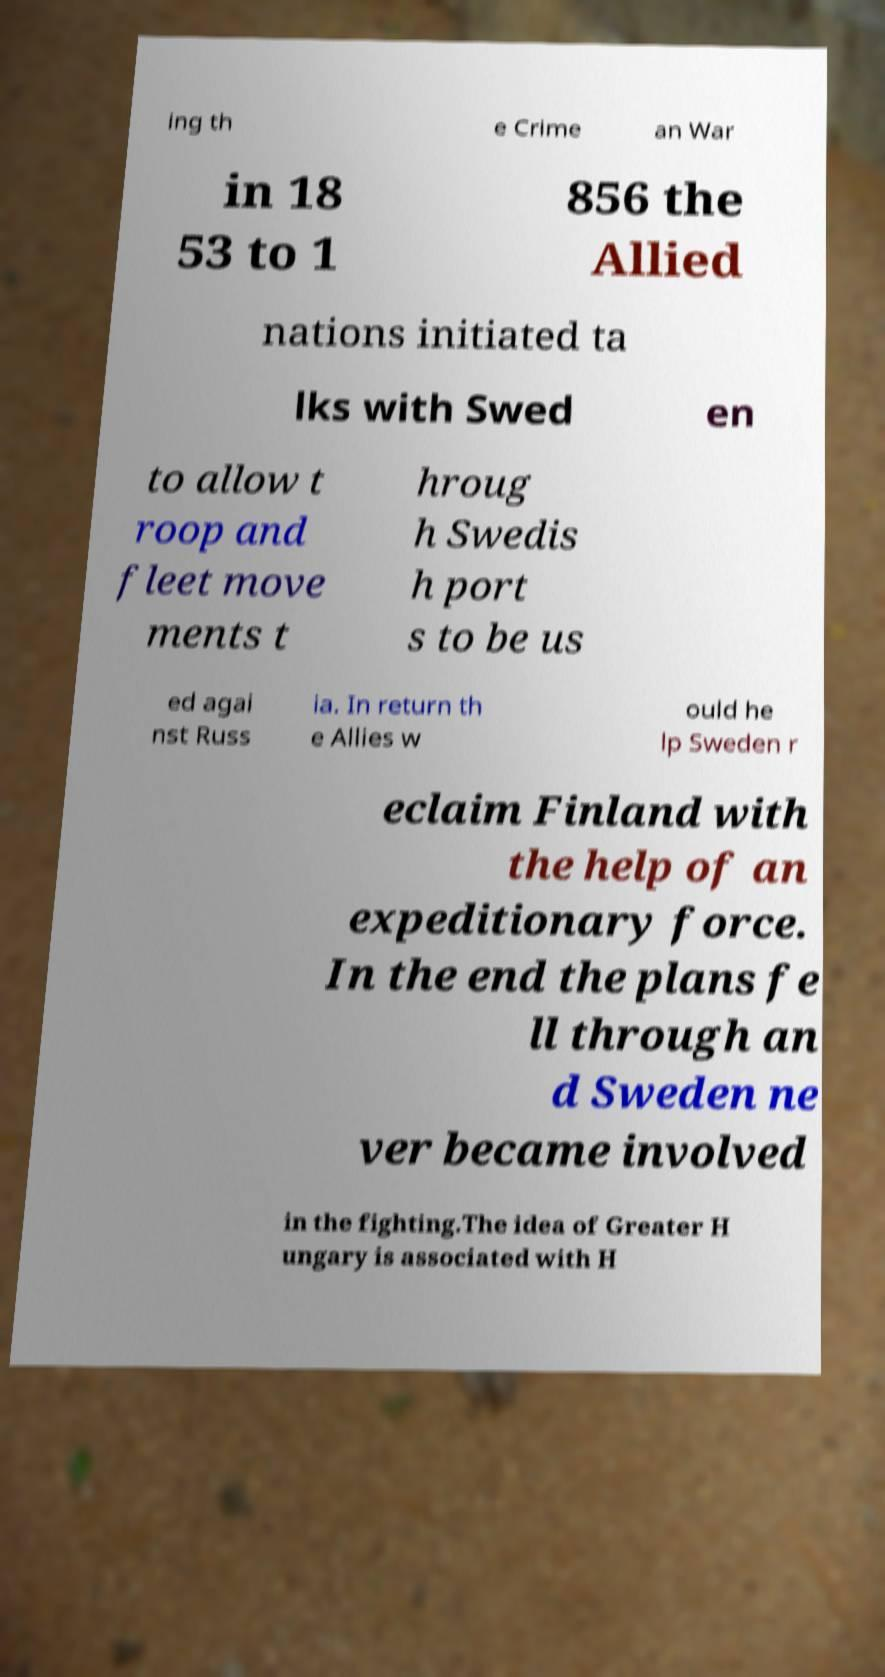Can you read and provide the text displayed in the image?This photo seems to have some interesting text. Can you extract and type it out for me? ing th e Crime an War in 18 53 to 1 856 the Allied nations initiated ta lks with Swed en to allow t roop and fleet move ments t hroug h Swedis h port s to be us ed agai nst Russ ia. In return th e Allies w ould he lp Sweden r eclaim Finland with the help of an expeditionary force. In the end the plans fe ll through an d Sweden ne ver became involved in the fighting.The idea of Greater H ungary is associated with H 